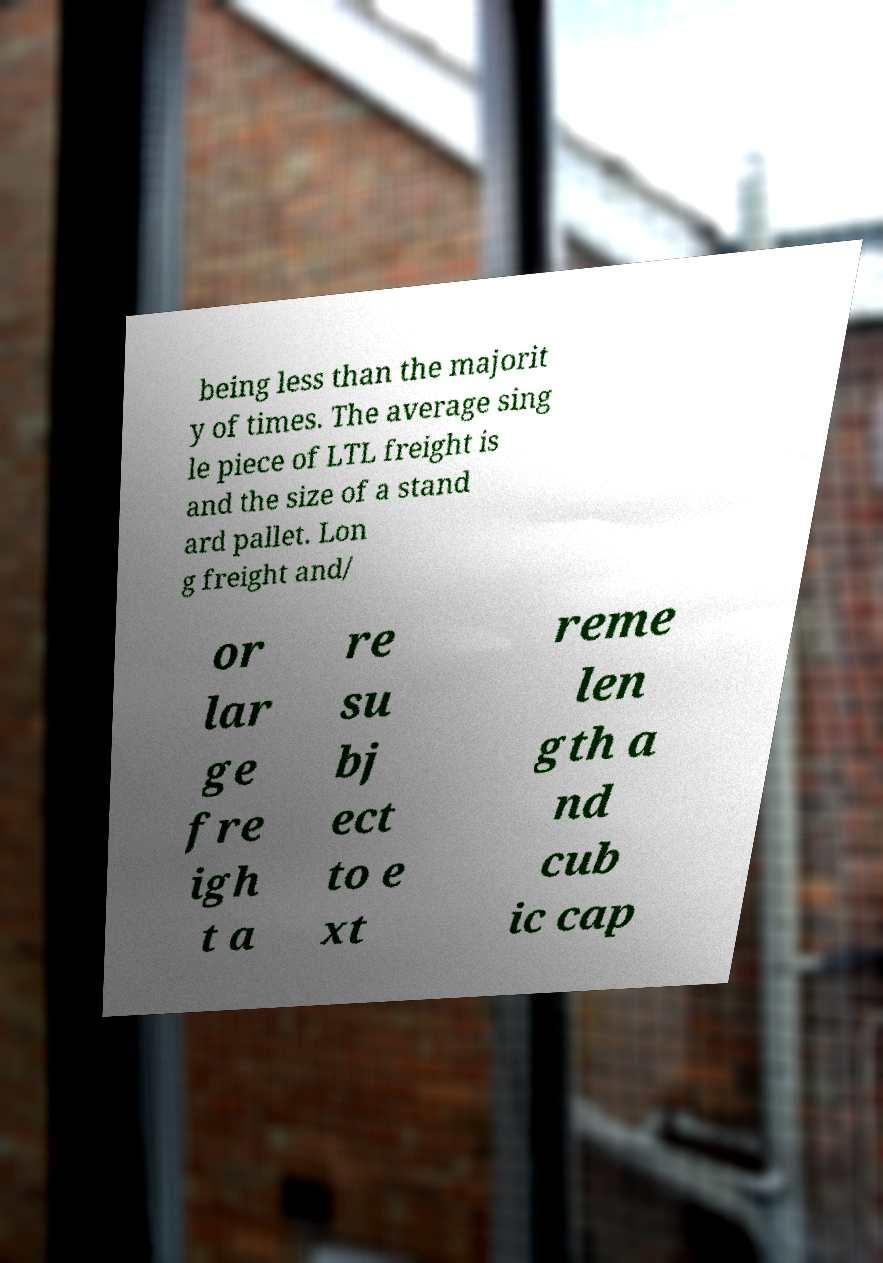Please read and relay the text visible in this image. What does it say? being less than the majorit y of times. The average sing le piece of LTL freight is and the size of a stand ard pallet. Lon g freight and/ or lar ge fre igh t a re su bj ect to e xt reme len gth a nd cub ic cap 